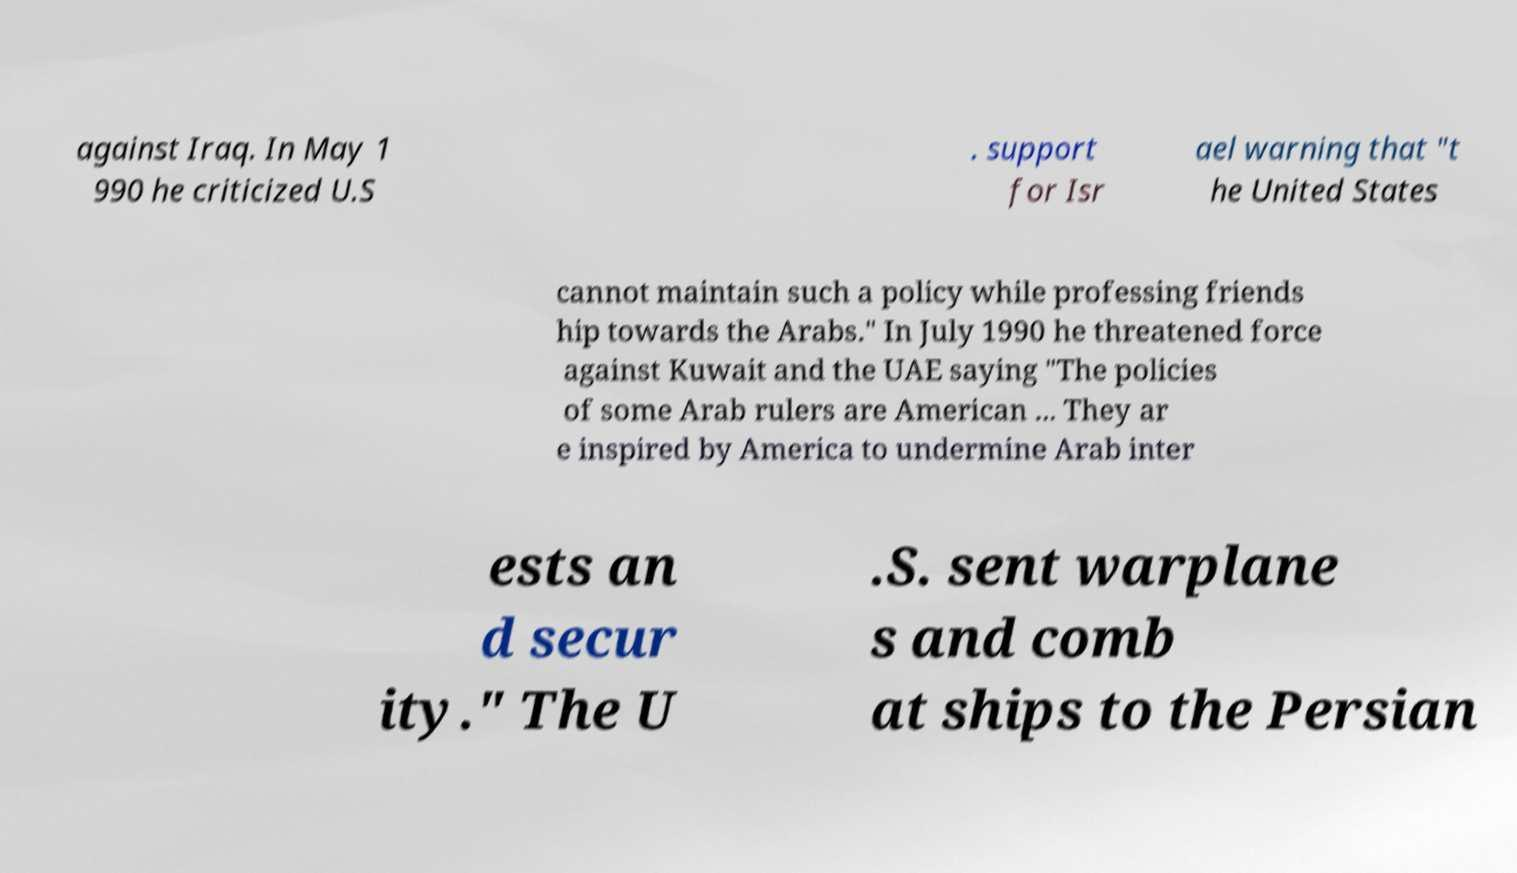There's text embedded in this image that I need extracted. Can you transcribe it verbatim? against Iraq. In May 1 990 he criticized U.S . support for Isr ael warning that "t he United States cannot maintain such a policy while professing friends hip towards the Arabs." In July 1990 he threatened force against Kuwait and the UAE saying "The policies of some Arab rulers are American ... They ar e inspired by America to undermine Arab inter ests an d secur ity." The U .S. sent warplane s and comb at ships to the Persian 